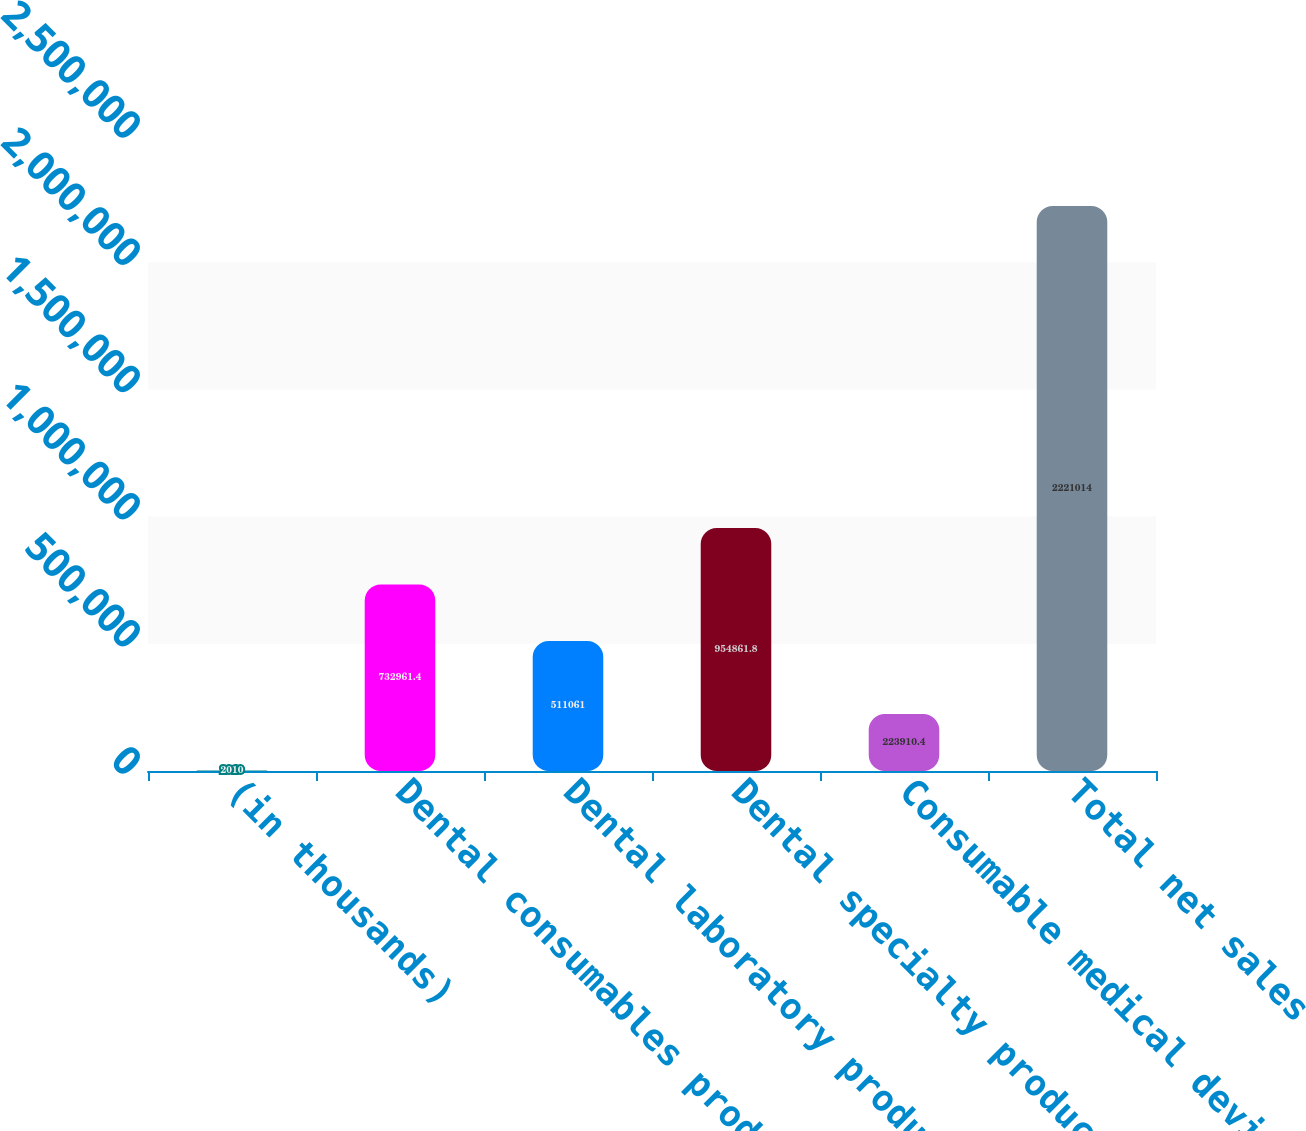<chart> <loc_0><loc_0><loc_500><loc_500><bar_chart><fcel>(in thousands)<fcel>Dental consumables products<fcel>Dental laboratory products<fcel>Dental specialty products<fcel>Consumable medical device<fcel>Total net sales<nl><fcel>2010<fcel>732961<fcel>511061<fcel>954862<fcel>223910<fcel>2.22101e+06<nl></chart> 